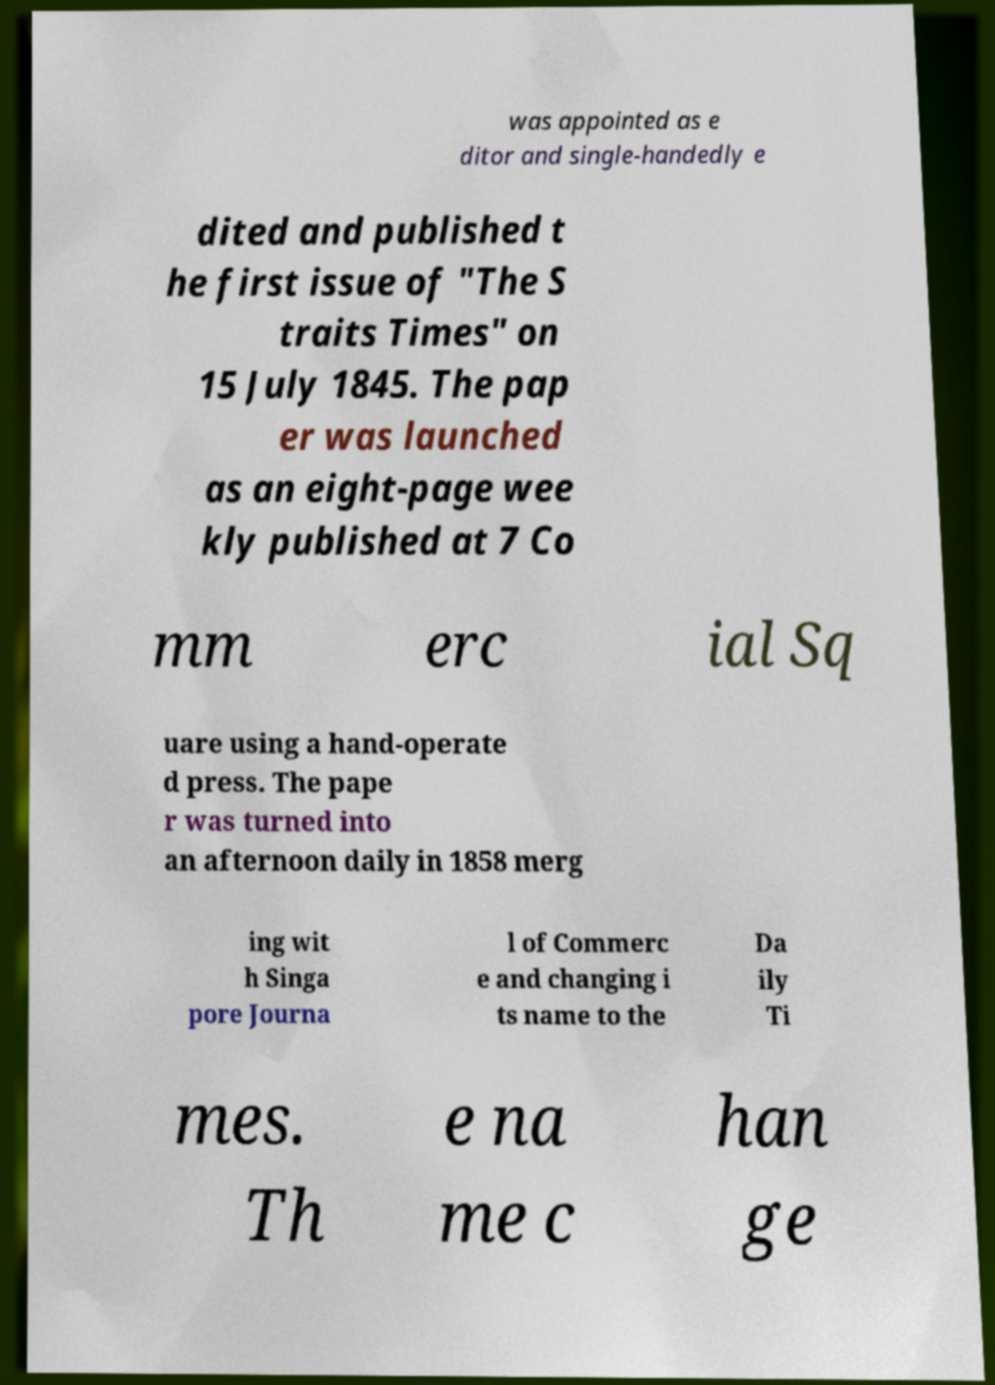For documentation purposes, I need the text within this image transcribed. Could you provide that? was appointed as e ditor and single-handedly e dited and published t he first issue of "The S traits Times" on 15 July 1845. The pap er was launched as an eight-page wee kly published at 7 Co mm erc ial Sq uare using a hand-operate d press. The pape r was turned into an afternoon daily in 1858 merg ing wit h Singa pore Journa l of Commerc e and changing i ts name to the Da ily Ti mes. Th e na me c han ge 